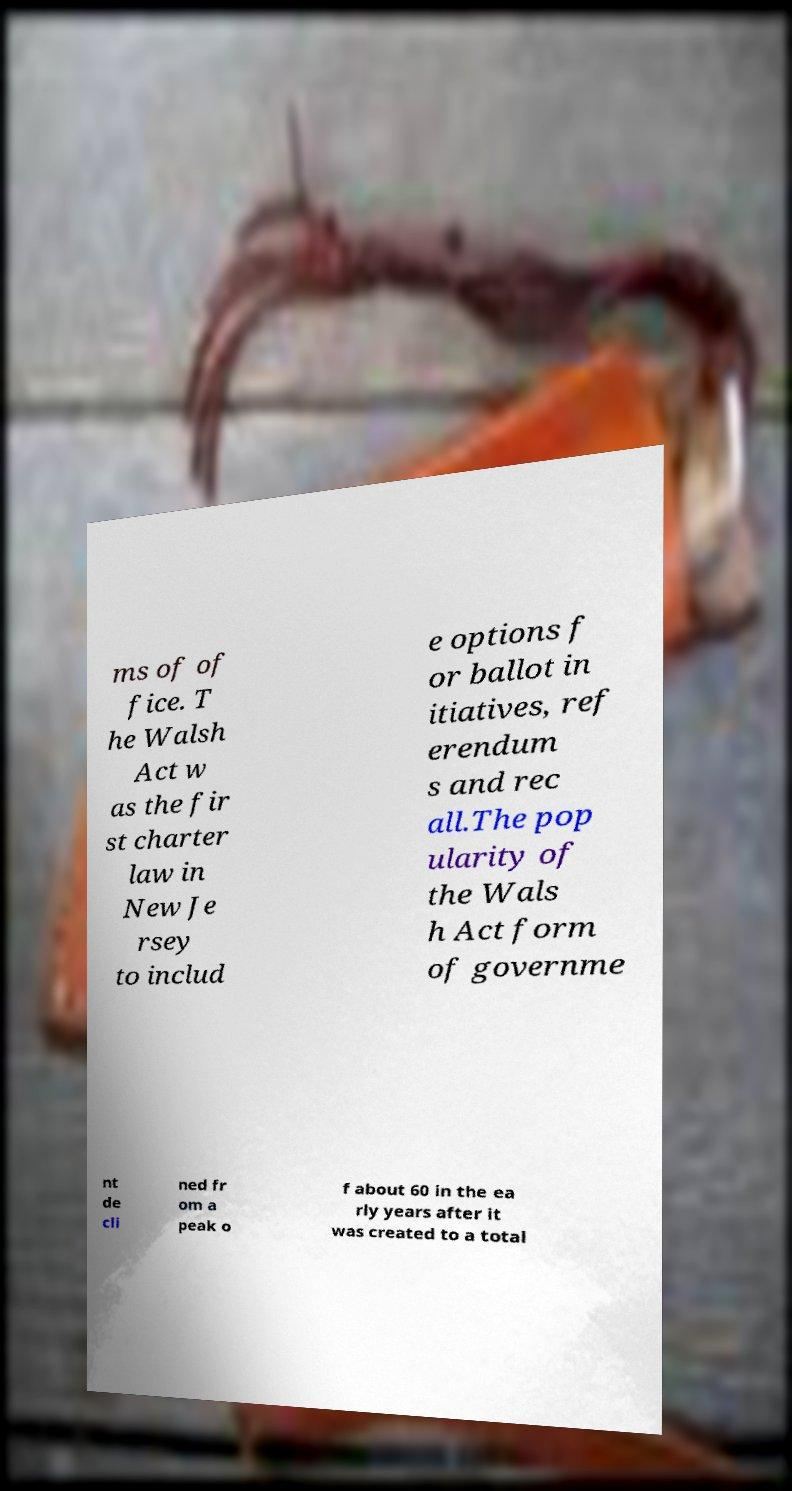I need the written content from this picture converted into text. Can you do that? ms of of fice. T he Walsh Act w as the fir st charter law in New Je rsey to includ e options f or ballot in itiatives, ref erendum s and rec all.The pop ularity of the Wals h Act form of governme nt de cli ned fr om a peak o f about 60 in the ea rly years after it was created to a total 